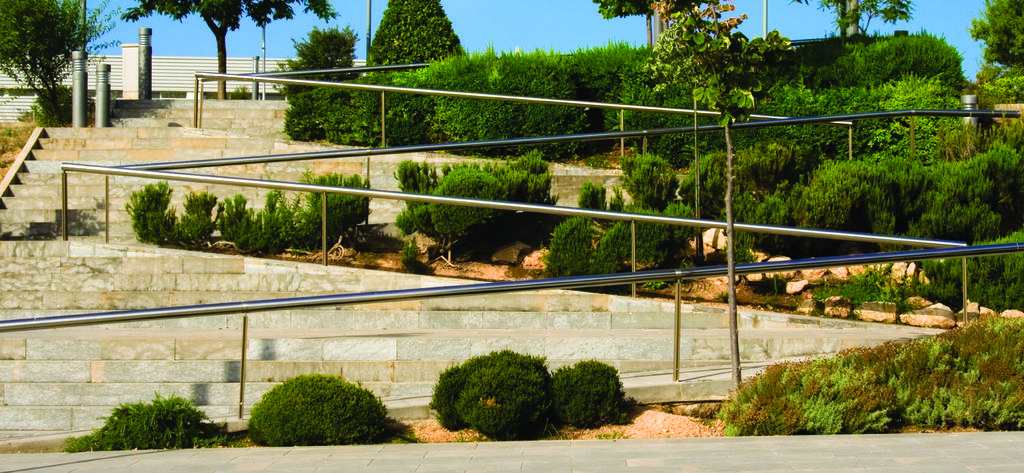What type of structure can be seen in the image? There are stairs, rods, bushes, trees, and poles visible in the image. What is at the bottom of the image? The bottom of the image contains a floor. What is at the top of the image? The top of the image contains the sky. How many ladybugs can be seen on the stairs in the image? There are no ladybugs present in the image. What time of day is depicted in the image? The time of day cannot be determined from the image, as there are no specific indicators of day or night. 